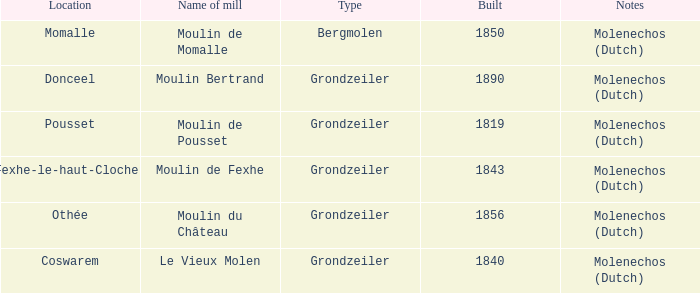What is year Built of the Moulin de Momalle Mill? 1850.0. 